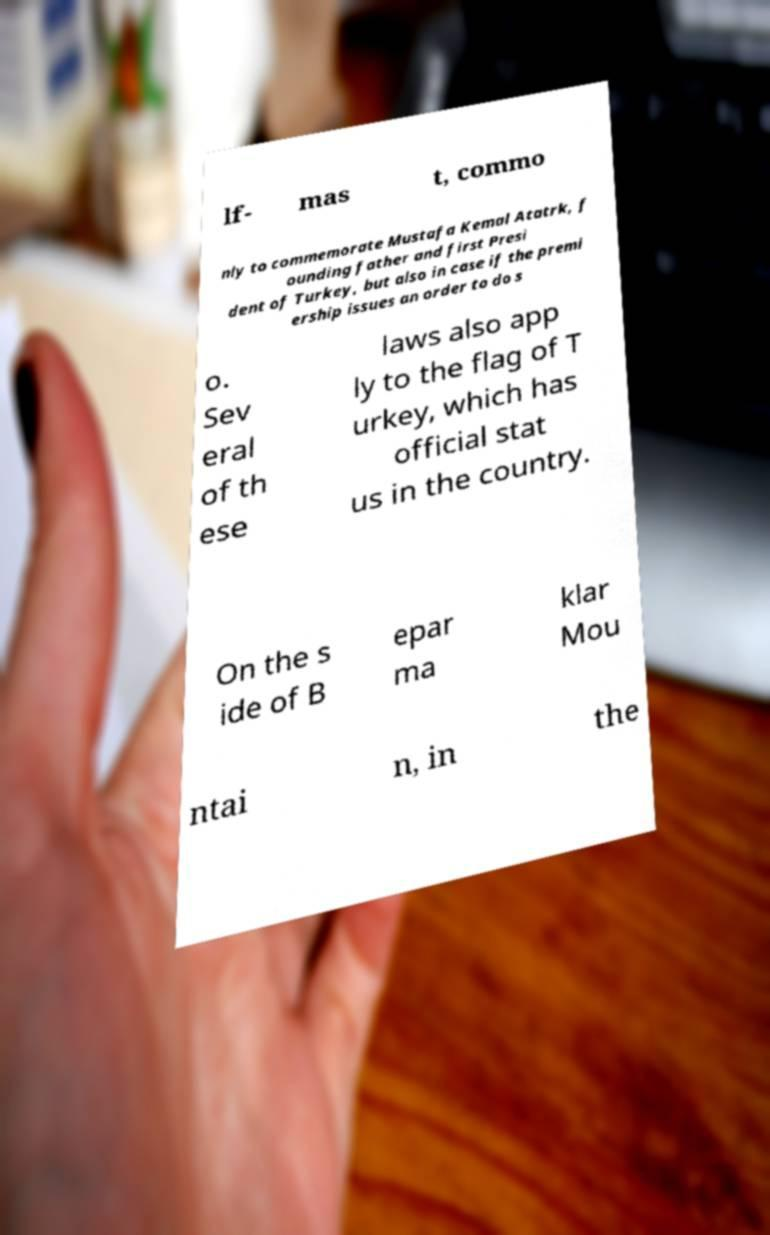Can you accurately transcribe the text from the provided image for me? lf- mas t, commo nly to commemorate Mustafa Kemal Atatrk, f ounding father and first Presi dent of Turkey, but also in case if the premi ership issues an order to do s o. Sev eral of th ese laws also app ly to the flag of T urkey, which has official stat us in the country. On the s ide of B epar ma klar Mou ntai n, in the 